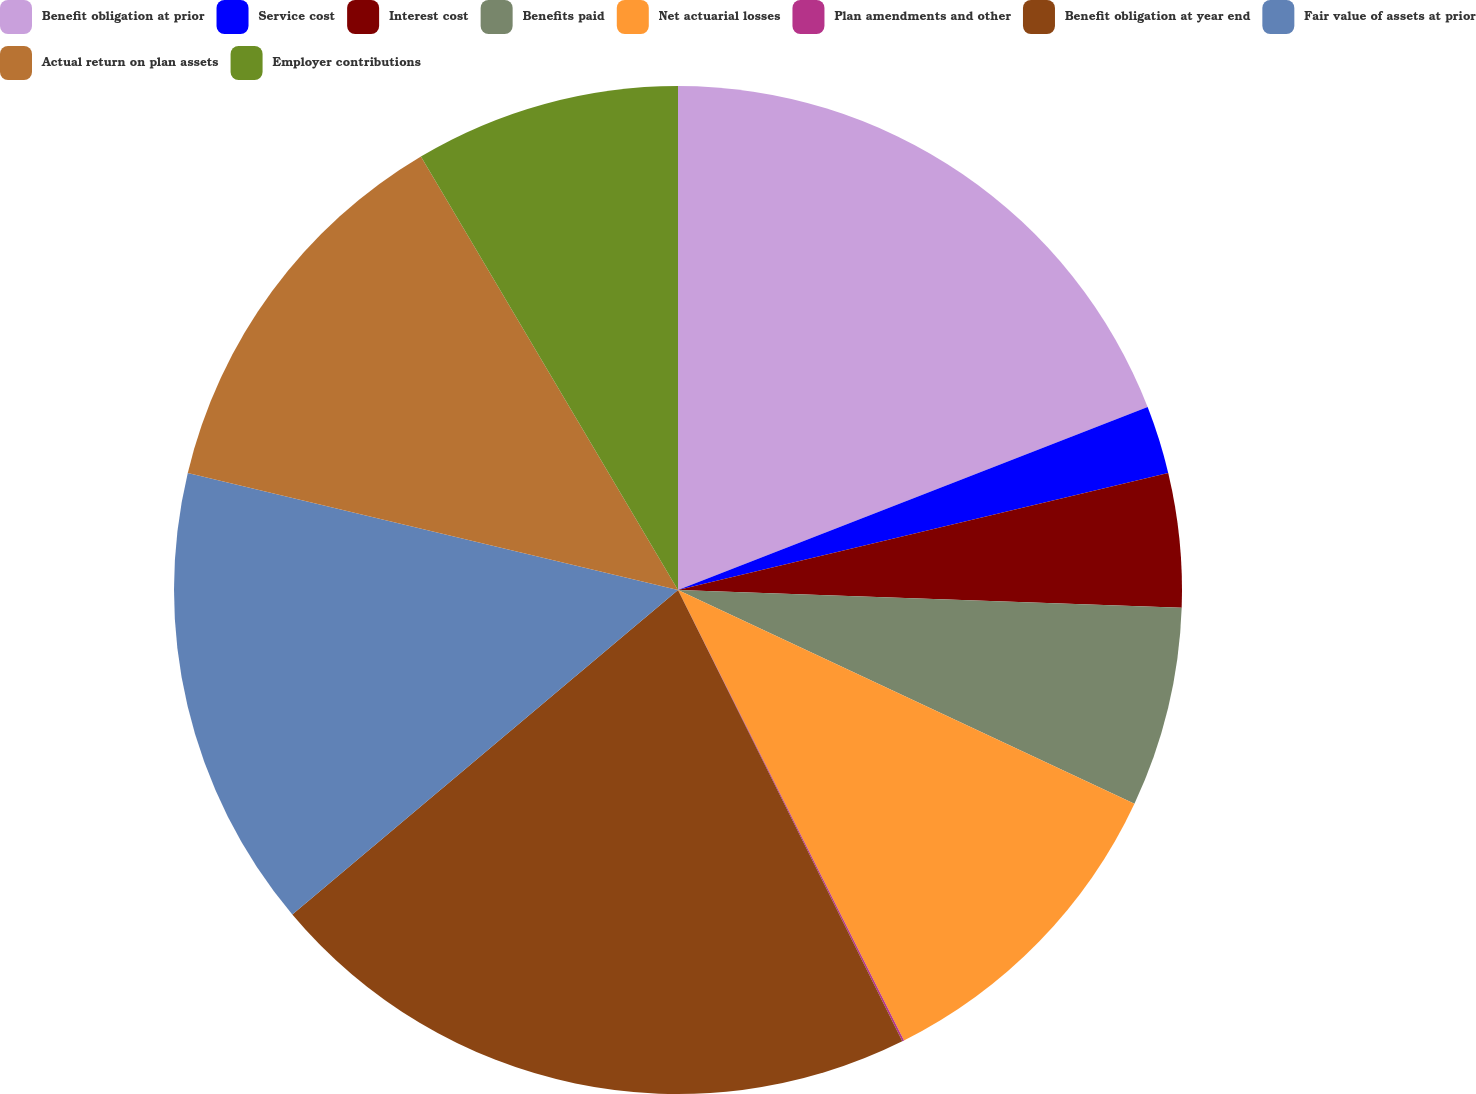Convert chart to OTSL. <chart><loc_0><loc_0><loc_500><loc_500><pie_chart><fcel>Benefit obligation at prior<fcel>Service cost<fcel>Interest cost<fcel>Benefits paid<fcel>Net actuarial losses<fcel>Plan amendments and other<fcel>Benefit obligation at year end<fcel>Fair value of assets at prior<fcel>Actual return on plan assets<fcel>Employer contributions<nl><fcel>19.09%<fcel>2.18%<fcel>4.29%<fcel>6.41%<fcel>10.63%<fcel>0.06%<fcel>21.21%<fcel>14.86%<fcel>12.75%<fcel>8.52%<nl></chart> 